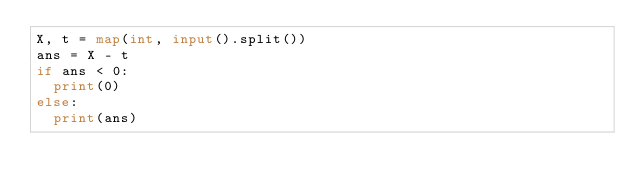Convert code to text. <code><loc_0><loc_0><loc_500><loc_500><_Python_>X, t = map(int, input().split())
ans = X - t
if ans < 0:
  print(0)
else:
  print(ans)</code> 